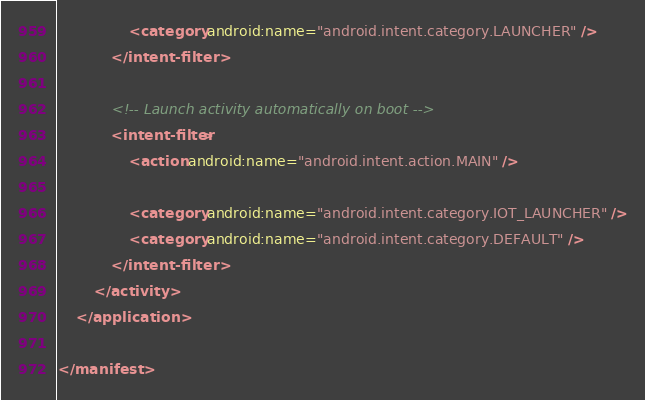<code> <loc_0><loc_0><loc_500><loc_500><_XML_>                <category android:name="android.intent.category.LAUNCHER" />
            </intent-filter>

            <!-- Launch activity automatically on boot -->
            <intent-filter>
                <action android:name="android.intent.action.MAIN" />

                <category android:name="android.intent.category.IOT_LAUNCHER" />
                <category android:name="android.intent.category.DEFAULT" />
            </intent-filter>
        </activity>
    </application>

</manifest>
</code> 